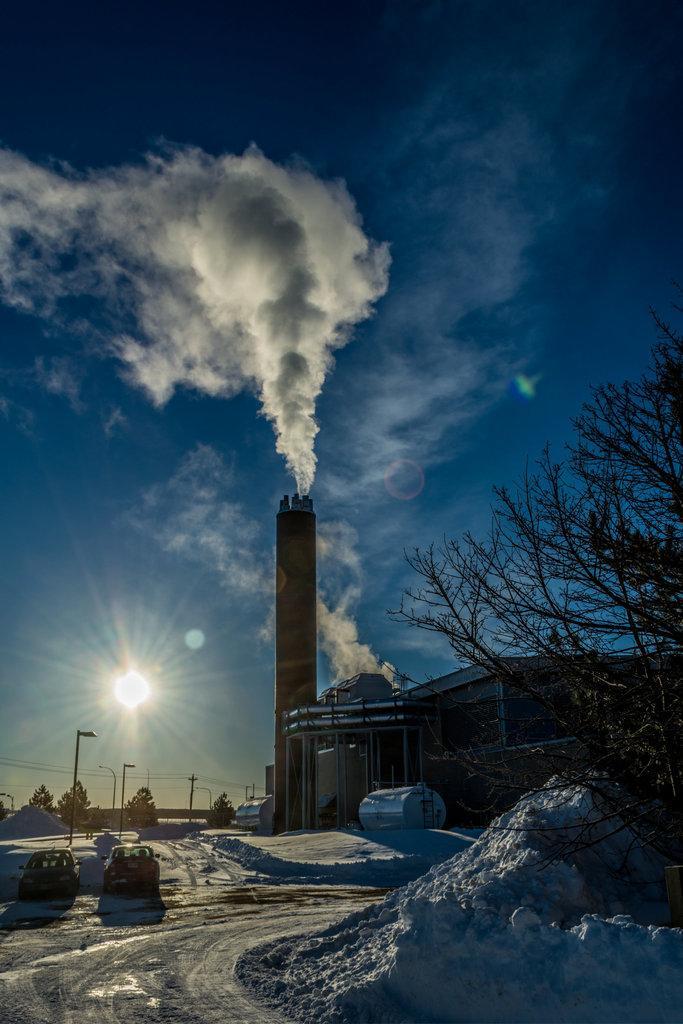How would you summarize this image in a sentence or two? In this image I can see a road on the left side and a tree on the right side. In the background I can see two vehicles, a building, few poles, few trees, the sun, clouds and the sky. On the top side of the image I can see the smoke and I can also see snow on the ground. 